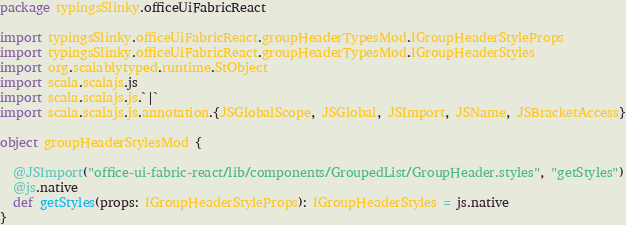<code> <loc_0><loc_0><loc_500><loc_500><_Scala_>package typingsSlinky.officeUiFabricReact

import typingsSlinky.officeUiFabricReact.groupHeaderTypesMod.IGroupHeaderStyleProps
import typingsSlinky.officeUiFabricReact.groupHeaderTypesMod.IGroupHeaderStyles
import org.scalablytyped.runtime.StObject
import scala.scalajs.js
import scala.scalajs.js.`|`
import scala.scalajs.js.annotation.{JSGlobalScope, JSGlobal, JSImport, JSName, JSBracketAccess}

object groupHeaderStylesMod {
  
  @JSImport("office-ui-fabric-react/lib/components/GroupedList/GroupHeader.styles", "getStyles")
  @js.native
  def getStyles(props: IGroupHeaderStyleProps): IGroupHeaderStyles = js.native
}
</code> 